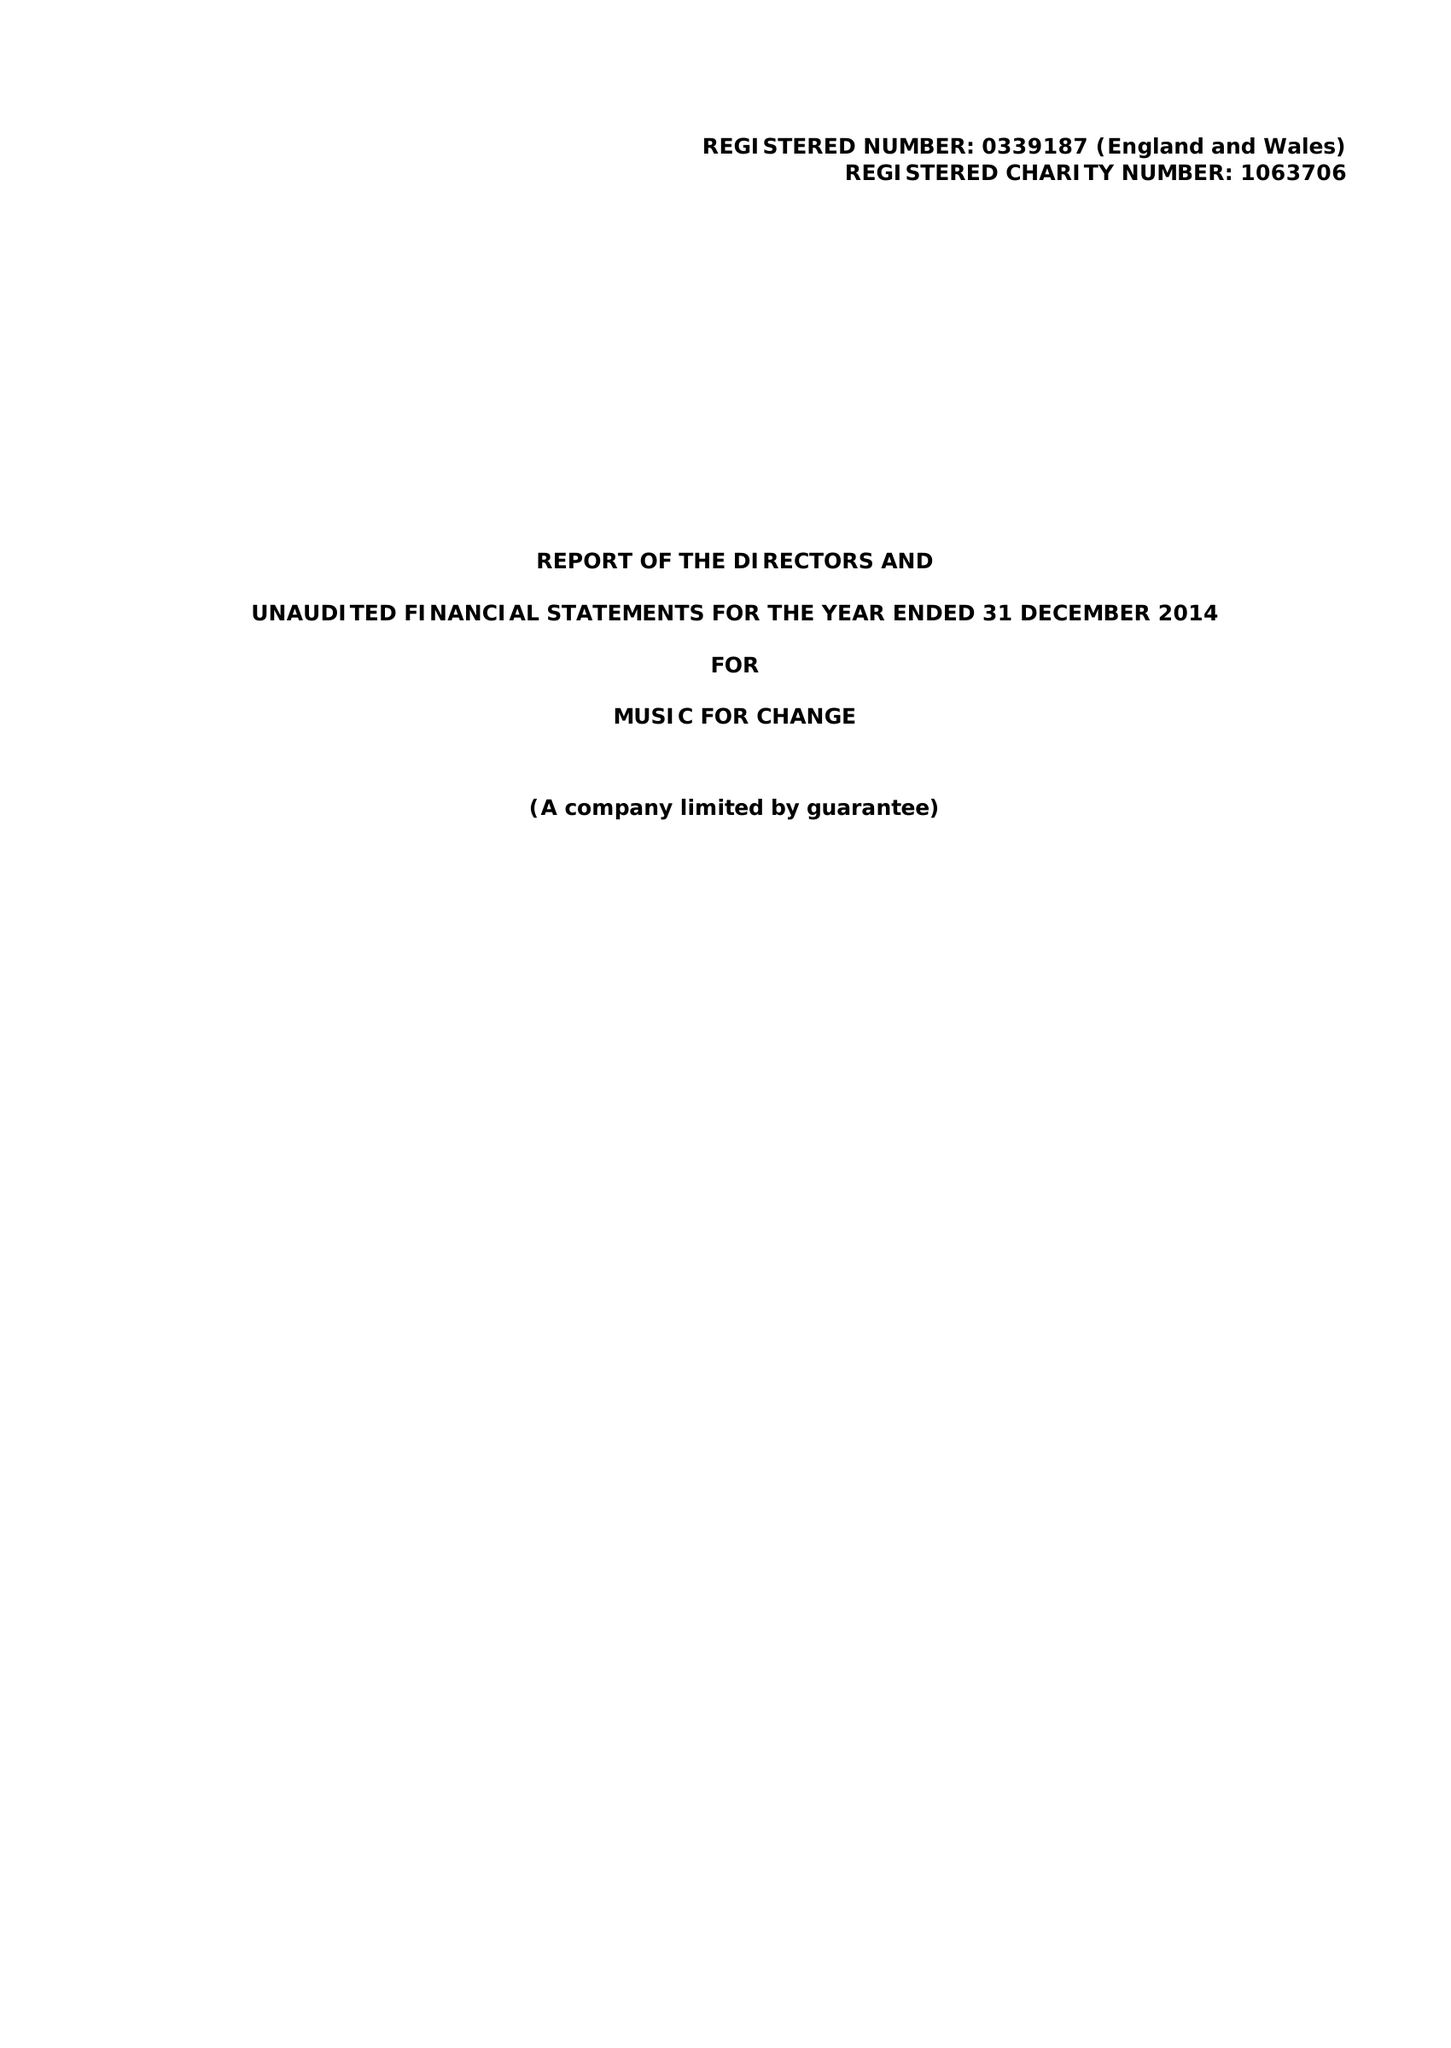What is the value for the address__post_town?
Answer the question using a single word or phrase. CANTERBURY 